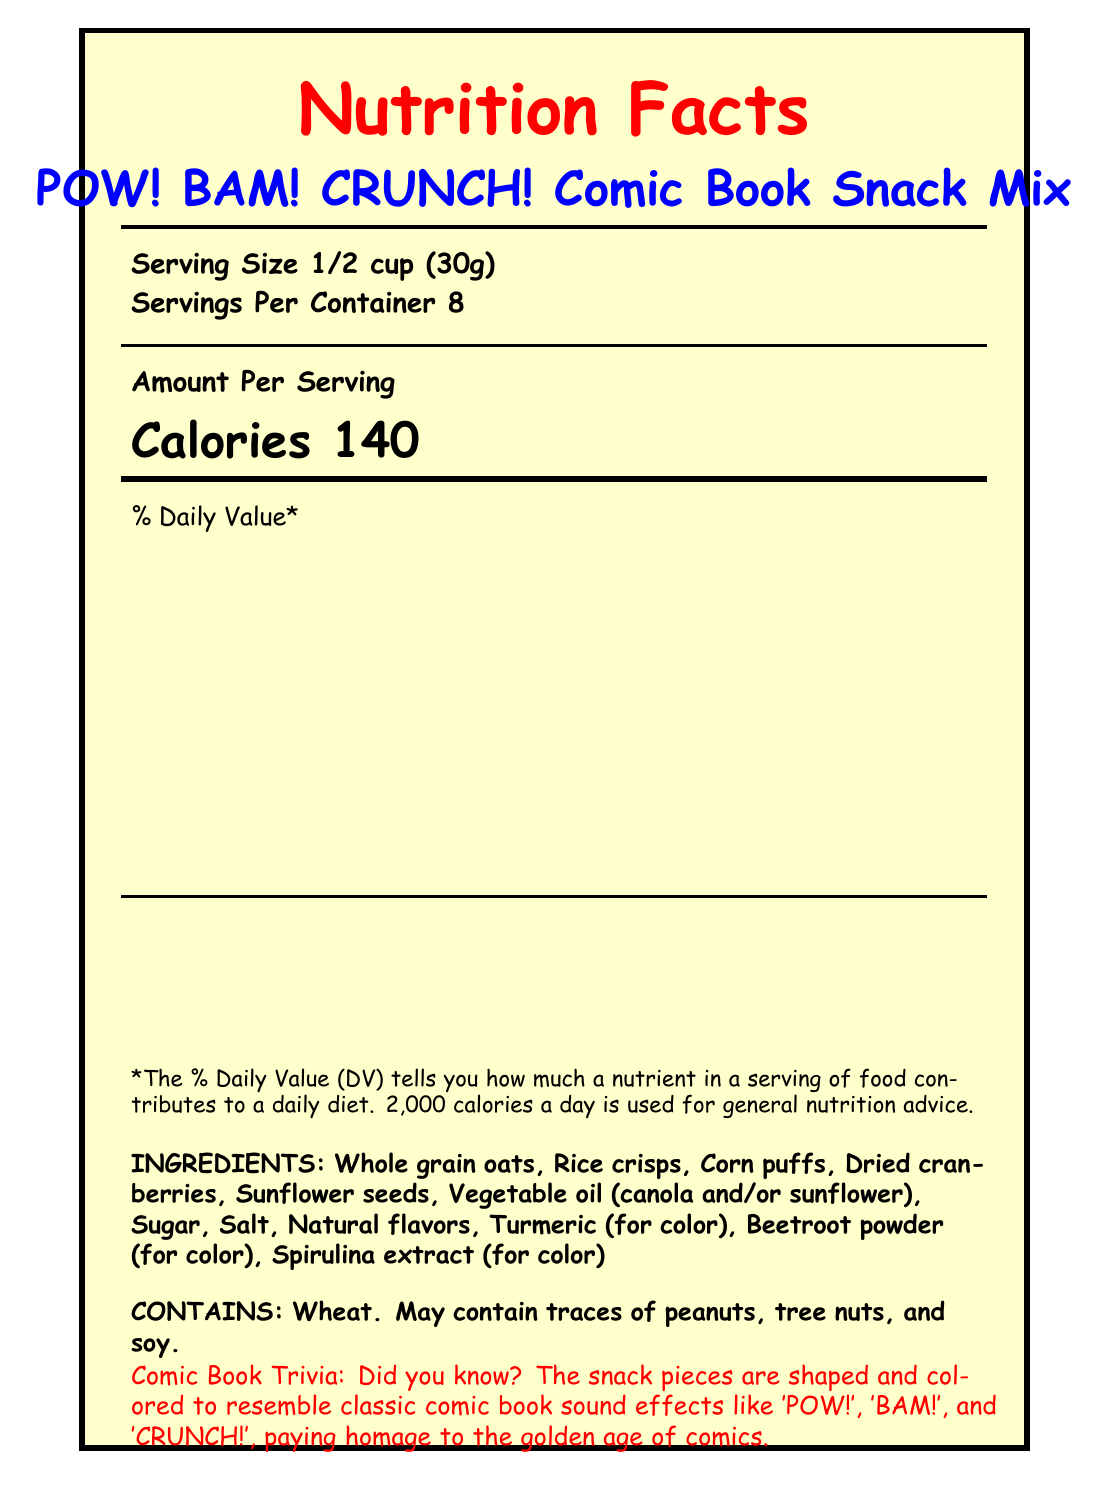what is the serving size of the POW! BAM! CRUNCH! Comic Book Snack Mix? The document specifies that the serving size is 1/2 cup (30g) next to the product name.
Answer: 1/2 cup (30g) how many servings are in one container? The document states that there are 8 servings per container.
Answer: 8 how many calories are there per serving? The document indicates that each serving contains 140 calories.
Answer: 140 what percentage of the daily value is sodium per serving? According to the document, sodium per serving makes up 8% of the daily value.
Answer: 8% how much protein is in one serving of the snack mix? The document lists that there are 3g of protein per serving.
Answer: 3g which of these allergens might be present in the snack mix? A. Peanuts B. Tree nuts C. Soy D. All of the above The document mentions that the snack might contain traces of peanuts, tree nuts, and soy.
Answer: D what is the amount of iron in one serving? A. 0.8mg B. 1.8mg C. 2.8mg D. 3.8mg The document states that one serving contains 1.8mg of iron.
Answer: B does the snack mix contain any cholesterol? The document indicates that the snack mix has 0mg of cholesterol, which means it contains no cholesterol.
Answer: No what is the main idea of the document? The document includes various sections like serving size, calories, total fat, carbohydrates, protein, vitamins, and minerals, as well as details about ingredients, allergens, and some comic book-related trivia.
Answer: The document provides the nutritional facts, ingredients, allergen information, and fun trivia of the POW! BAM! CRUNCH! Comic Book Snack Mix. what colors are used to draw attention to the document's sections? The document uses comicred (Red), comicblue (Blue), and comicyellow (Yellow) to emphasize different sections.
Answer: Red, blue, and yellow what is the flavor profile of the snack mix? The document describes the flavor profile as a perfect balance of sweet and salty, with a satisfying crunch.
Answer: A balance of sweet and salty with a satisfying crunch what is the ingredient used for coloring that is also a common spice? According to the ingredient list, turmeric is used for coloring.
Answer: Turmeric what collectible item is included with the snack mix? The document notes under the collector note section that each package contains a limited edition collectible trading card with artwork from indie comic artists.
Answer: A limited edition collectible trading card featuring artwork from indie comic artists how much added sugar does the snack mix contain per serving? The document specifies that there are 3g of added sugars per serving.
Answer: 3g how much dietary fiber is in one serving of the snack mix? The document indicates that each serving contains 2g of dietary fiber.
Answer: 2g does the document provide instructions on where to buy the snack mix? The document does not mention where to buy the snack mix; it focuses solely on the nutritional facts and other product details.
Answer: Not enough information 